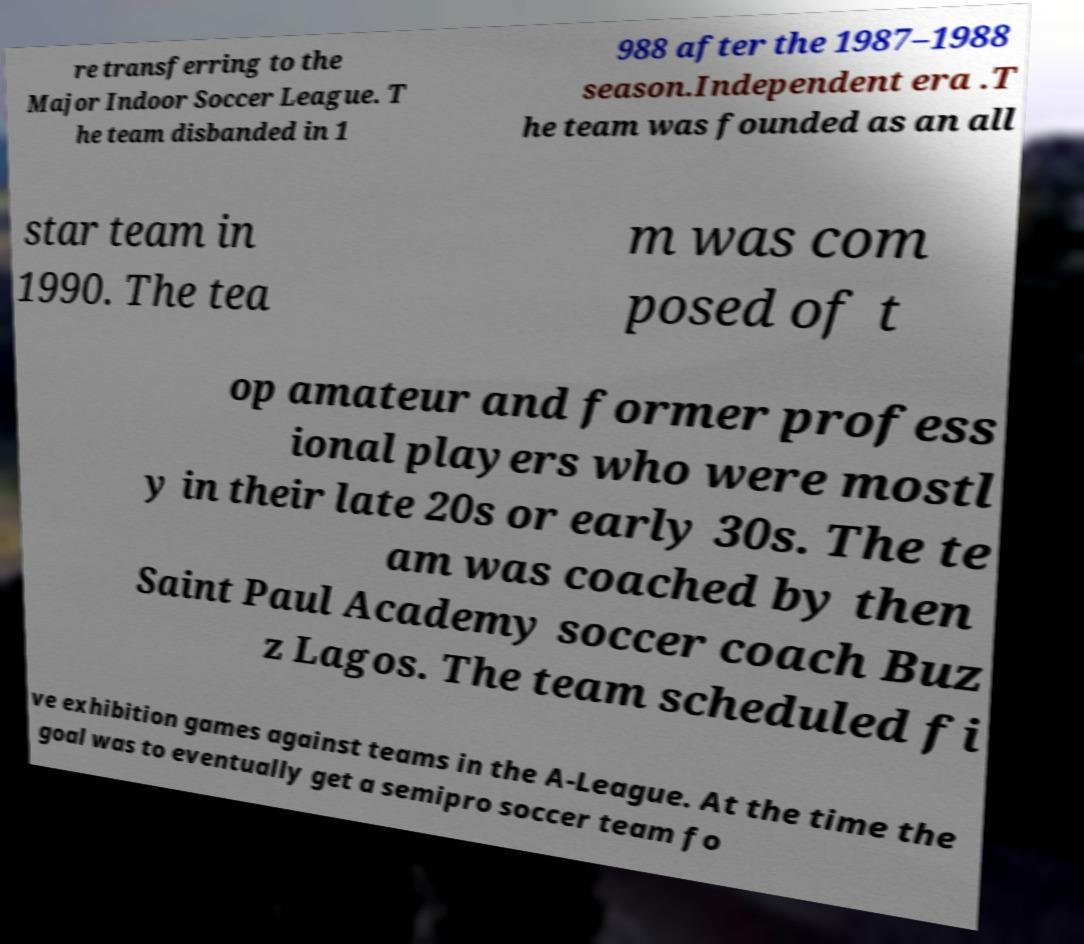Please identify and transcribe the text found in this image. re transferring to the Major Indoor Soccer League. T he team disbanded in 1 988 after the 1987–1988 season.Independent era .T he team was founded as an all star team in 1990. The tea m was com posed of t op amateur and former profess ional players who were mostl y in their late 20s or early 30s. The te am was coached by then Saint Paul Academy soccer coach Buz z Lagos. The team scheduled fi ve exhibition games against teams in the A-League. At the time the goal was to eventually get a semipro soccer team fo 